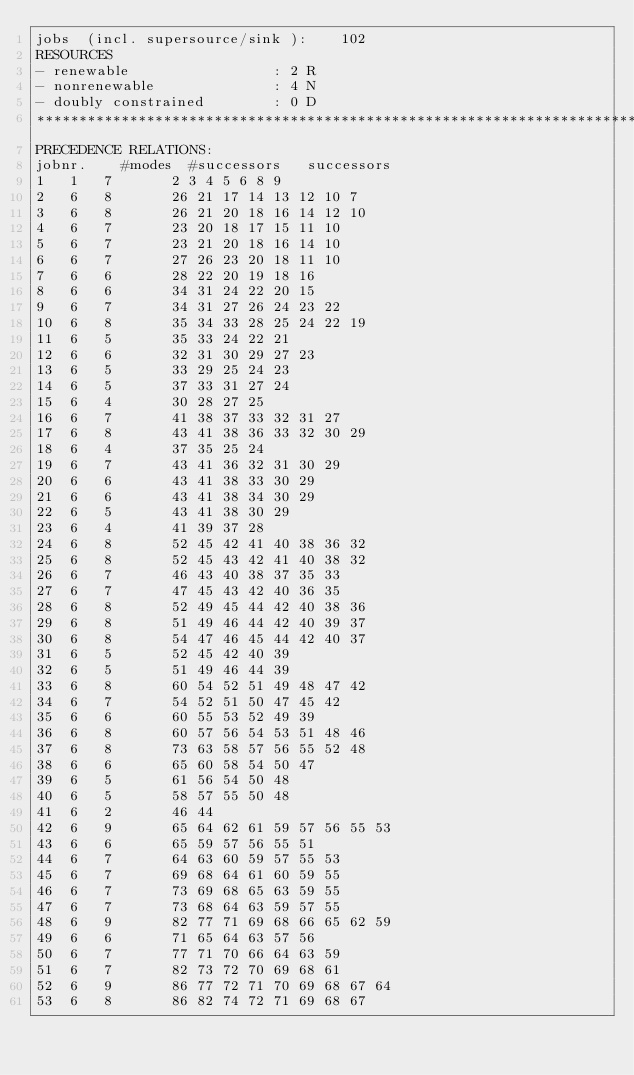<code> <loc_0><loc_0><loc_500><loc_500><_ObjectiveC_>jobs  (incl. supersource/sink ):	102
RESOURCES
- renewable                 : 2 R
- nonrenewable              : 4 N
- doubly constrained        : 0 D
************************************************************************
PRECEDENCE RELATIONS:
jobnr.    #modes  #successors   successors
1	1	7		2 3 4 5 6 8 9 
2	6	8		26 21 17 14 13 12 10 7 
3	6	8		26 21 20 18 16 14 12 10 
4	6	7		23 20 18 17 15 11 10 
5	6	7		23 21 20 18 16 14 10 
6	6	7		27 26 23 20 18 11 10 
7	6	6		28 22 20 19 18 16 
8	6	6		34 31 24 22 20 15 
9	6	7		34 31 27 26 24 23 22 
10	6	8		35 34 33 28 25 24 22 19 
11	6	5		35 33 24 22 21 
12	6	6		32 31 30 29 27 23 
13	6	5		33 29 25 24 23 
14	6	5		37 33 31 27 24 
15	6	4		30 28 27 25 
16	6	7		41 38 37 33 32 31 27 
17	6	8		43 41 38 36 33 32 30 29 
18	6	4		37 35 25 24 
19	6	7		43 41 36 32 31 30 29 
20	6	6		43 41 38 33 30 29 
21	6	6		43 41 38 34 30 29 
22	6	5		43 41 38 30 29 
23	6	4		41 39 37 28 
24	6	8		52 45 42 41 40 38 36 32 
25	6	8		52 45 43 42 41 40 38 32 
26	6	7		46 43 40 38 37 35 33 
27	6	7		47 45 43 42 40 36 35 
28	6	8		52 49 45 44 42 40 38 36 
29	6	8		51 49 46 44 42 40 39 37 
30	6	8		54 47 46 45 44 42 40 37 
31	6	5		52 45 42 40 39 
32	6	5		51 49 46 44 39 
33	6	8		60 54 52 51 49 48 47 42 
34	6	7		54 52 51 50 47 45 42 
35	6	6		60 55 53 52 49 39 
36	6	8		60 57 56 54 53 51 48 46 
37	6	8		73 63 58 57 56 55 52 48 
38	6	6		65 60 58 54 50 47 
39	6	5		61 56 54 50 48 
40	6	5		58 57 55 50 48 
41	6	2		46 44 
42	6	9		65 64 62 61 59 57 56 55 53 
43	6	6		65 59 57 56 55 51 
44	6	7		64 63 60 59 57 55 53 
45	6	7		69 68 64 61 60 59 55 
46	6	7		73 69 68 65 63 59 55 
47	6	7		73 68 64 63 59 57 55 
48	6	9		82 77 71 69 68 66 65 62 59 
49	6	6		71 65 64 63 57 56 
50	6	7		77 71 70 66 64 63 59 
51	6	7		82 73 72 70 69 68 61 
52	6	9		86 77 72 71 70 69 68 67 64 
53	6	8		86 82 74 72 71 69 68 67 </code> 